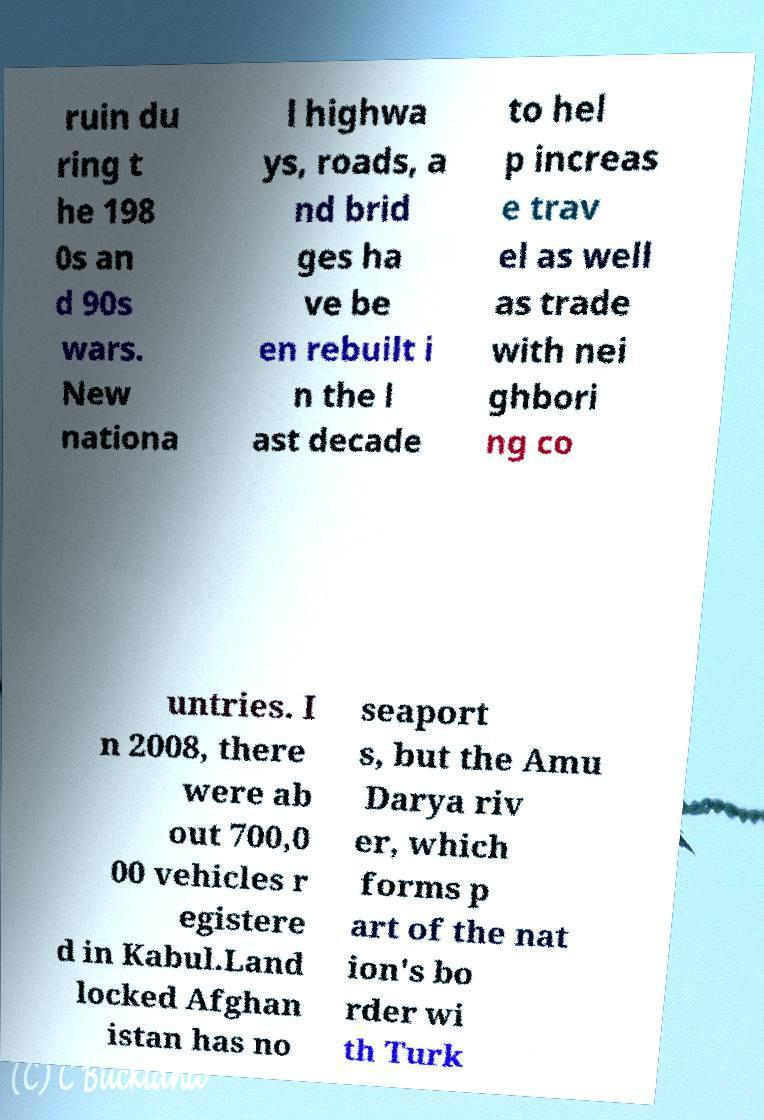There's text embedded in this image that I need extracted. Can you transcribe it verbatim? ruin du ring t he 198 0s an d 90s wars. New nationa l highwa ys, roads, a nd brid ges ha ve be en rebuilt i n the l ast decade to hel p increas e trav el as well as trade with nei ghbori ng co untries. I n 2008, there were ab out 700,0 00 vehicles r egistere d in Kabul.Land locked Afghan istan has no seaport s, but the Amu Darya riv er, which forms p art of the nat ion's bo rder wi th Turk 